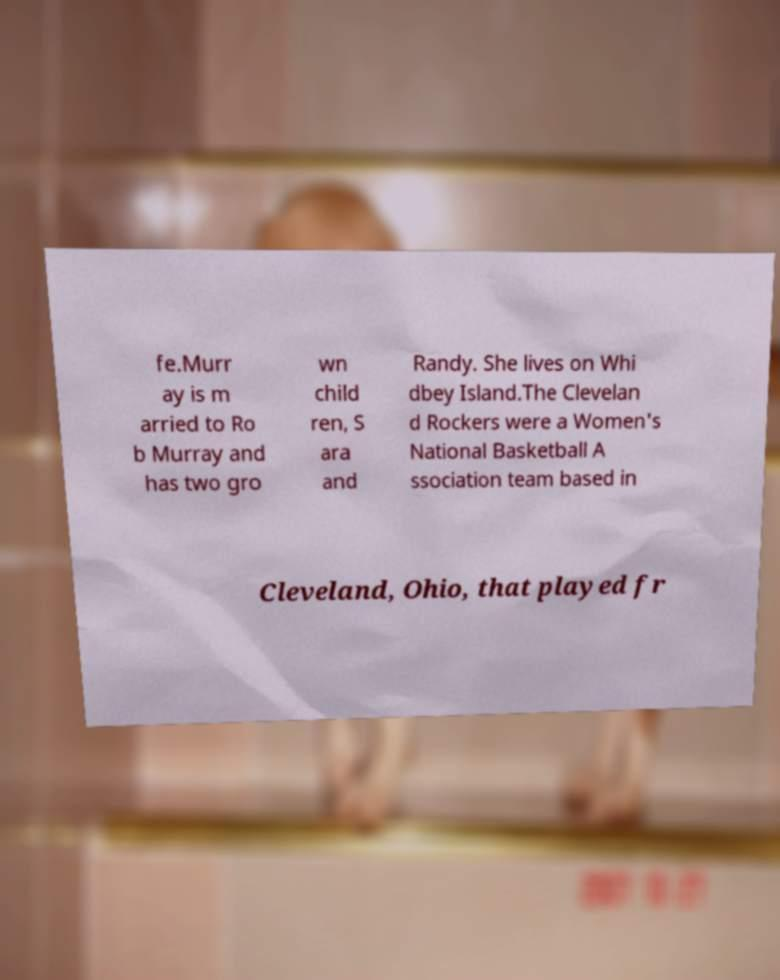There's text embedded in this image that I need extracted. Can you transcribe it verbatim? fe.Murr ay is m arried to Ro b Murray and has two gro wn child ren, S ara and Randy. She lives on Whi dbey Island.The Clevelan d Rockers were a Women's National Basketball A ssociation team based in Cleveland, Ohio, that played fr 